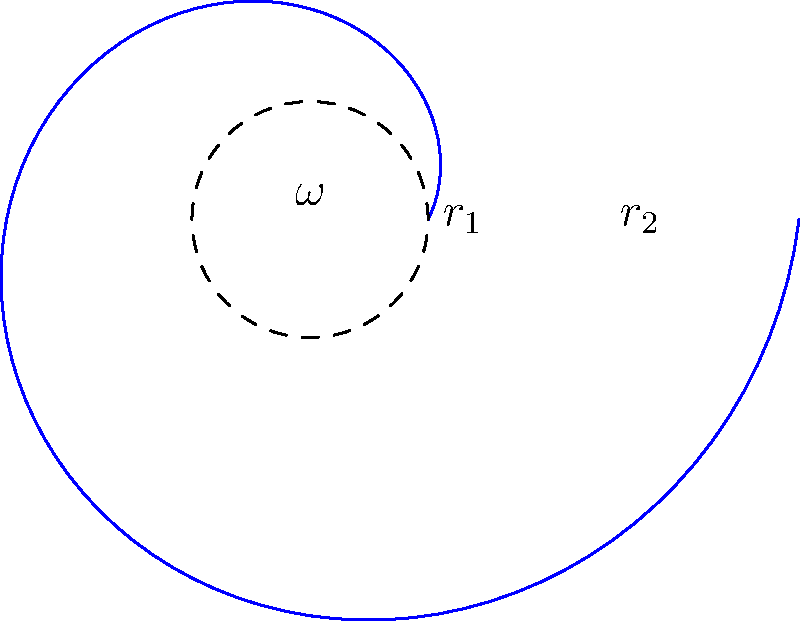In a centrifugal pump impeller rotating at angular velocity $\omega$, the pressure distribution from the inner radius $r_1$ to the outer radius $r_2$ can be approximated by the equation:

$$ p(r) = p_1 + \frac{1}{2}\rho\omega^2(r^2 - r_1^2) $$

Where $p_1$ is the pressure at $r_1$, $\rho$ is the fluid density, and $r$ is the radial distance from the center. If the pressure at $r_2$ is measured to be 150 kPa higher than at $r_1$, what is the angular velocity $\omega$ of the impeller? Assume $\rho = 1000$ kg/m³, $r_1 = 0.05$ m, and $r_2 = 0.15$ m. To solve this problem, we'll follow these steps:

1) We know that the pressure difference between $r_2$ and $r_1$ is 150 kPa:

   $p(r_2) - p(r_1) = 150000$ Pa

2) Substituting the equation for $p(r)$ at $r_2$ and $r_1$:

   $[p_1 + \frac{1}{2}\rho\omega^2(r_2^2 - r_1^2)] - [p_1 + \frac{1}{2}\rho\omega^2(r_1^2 - r_1^2)] = 150000$

3) Simplify:

   $\frac{1}{2}\rho\omega^2(r_2^2 - r_1^2) = 150000$

4) Substitute the known values:

   $\frac{1}{2} \cdot 1000 \cdot \omega^2 \cdot (0.15^2 - 0.05^2) = 150000$

5) Simplify:

   $500\omega^2 \cdot 0.02 = 150000$

6) Solve for $\omega$:

   $\omega^2 = \frac{150000}{500 \cdot 0.02} = 15000$

   $\omega = \sqrt{15000} \approx 122.47$ rad/s

7) Convert to RPM if desired:

   $\omega = 122.47 \cdot \frac{60}{2\pi} \approx 1170$ RPM

Therefore, the angular velocity of the impeller is approximately 122.47 rad/s or 1170 RPM.
Answer: 122.47 rad/s 